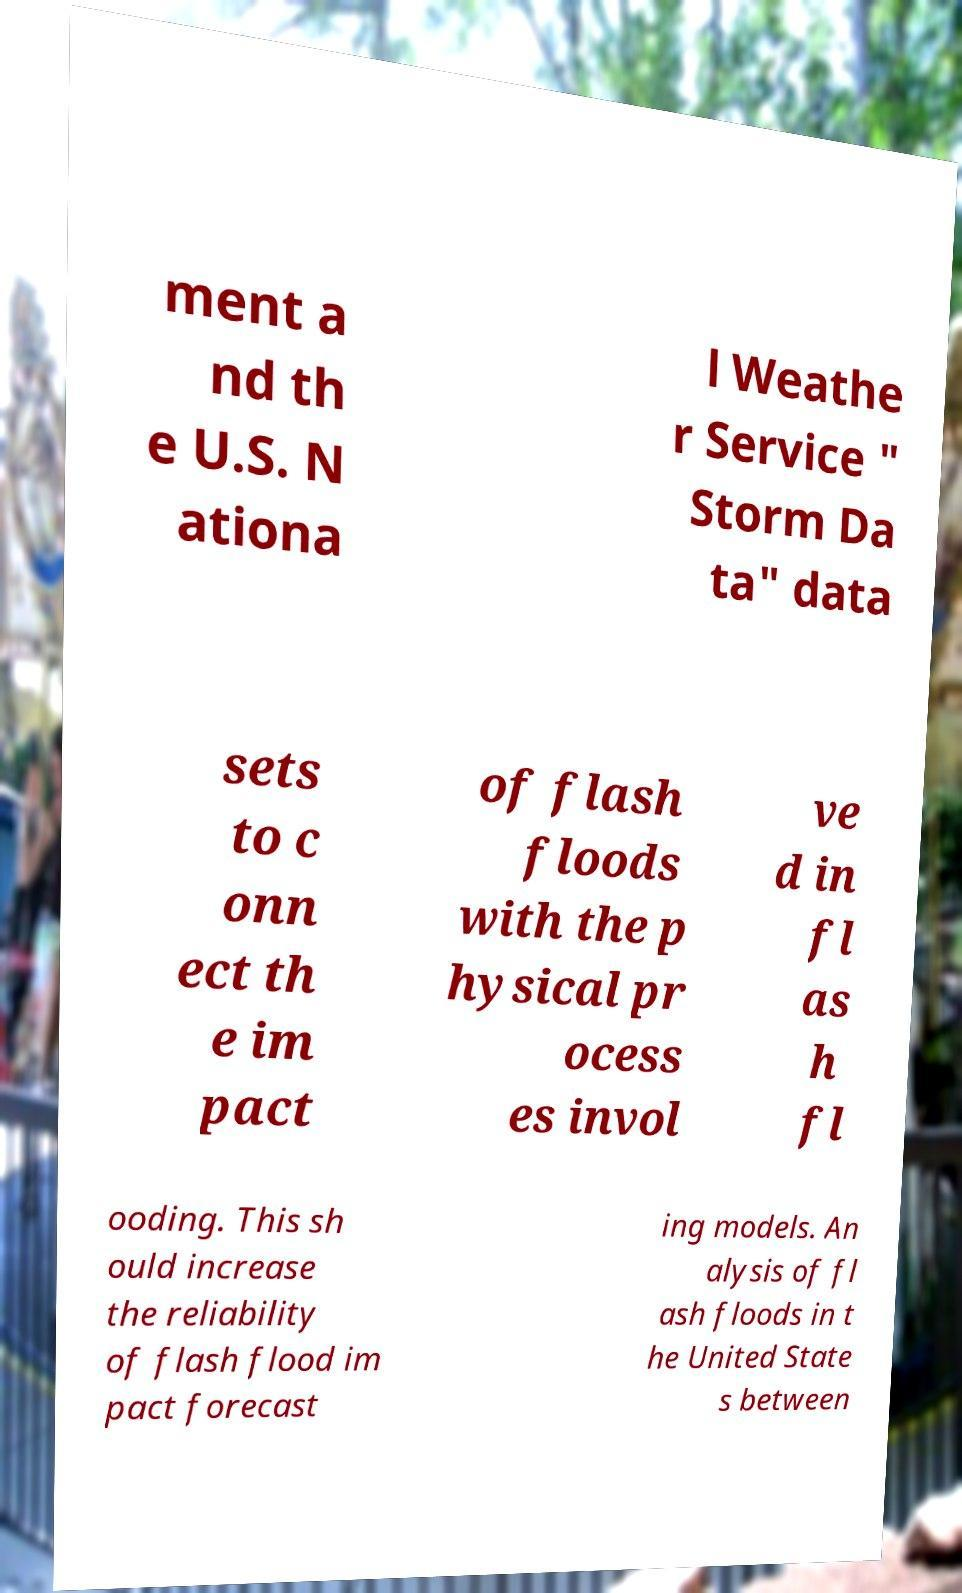There's text embedded in this image that I need extracted. Can you transcribe it verbatim? ment a nd th e U.S. N ationa l Weathe r Service " Storm Da ta" data sets to c onn ect th e im pact of flash floods with the p hysical pr ocess es invol ve d in fl as h fl ooding. This sh ould increase the reliability of flash flood im pact forecast ing models. An alysis of fl ash floods in t he United State s between 